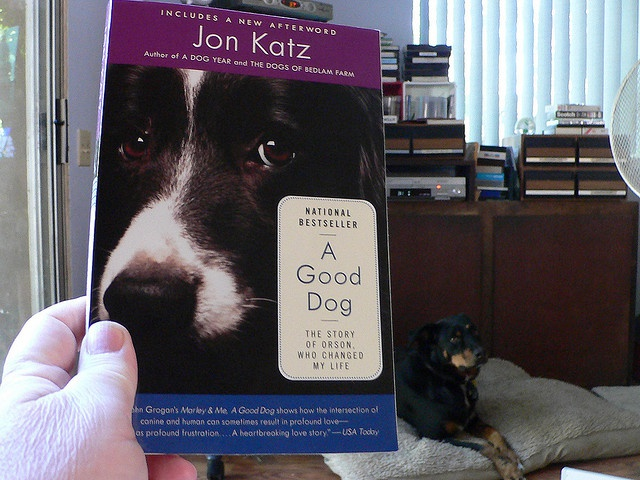Describe the objects in this image and their specific colors. I can see book in darkgray, black, purple, navy, and lightgray tones, dog in darkgray, black, and gray tones, people in darkgray, lavender, and lightpink tones, bed in darkgray, gray, and black tones, and dog in darkgray, black, and gray tones in this image. 